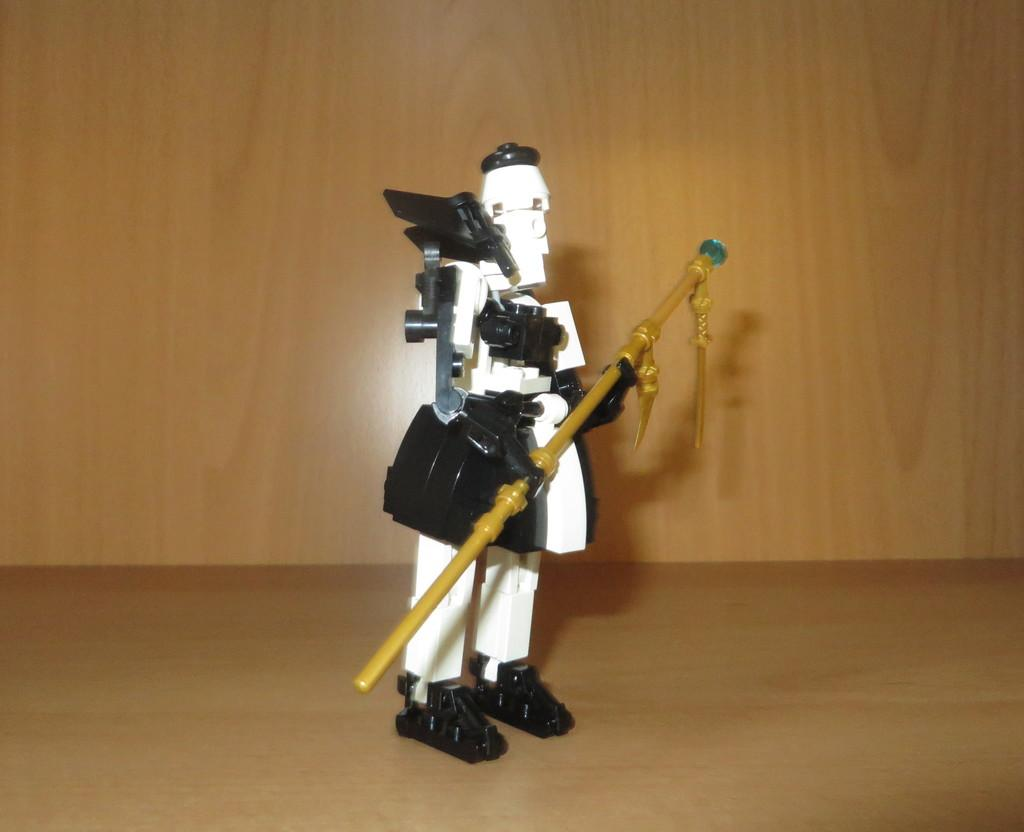What object can be seen in the image? There is a toy in the image. Where is the toy located? The toy is on a surface. What can be seen in the background of the image? There is a wall visible in the background of the image. What type of glue is being used to hold the toy together in the image? There is no glue present in the image, and the toy does not appear to be held together by any adhesive. 